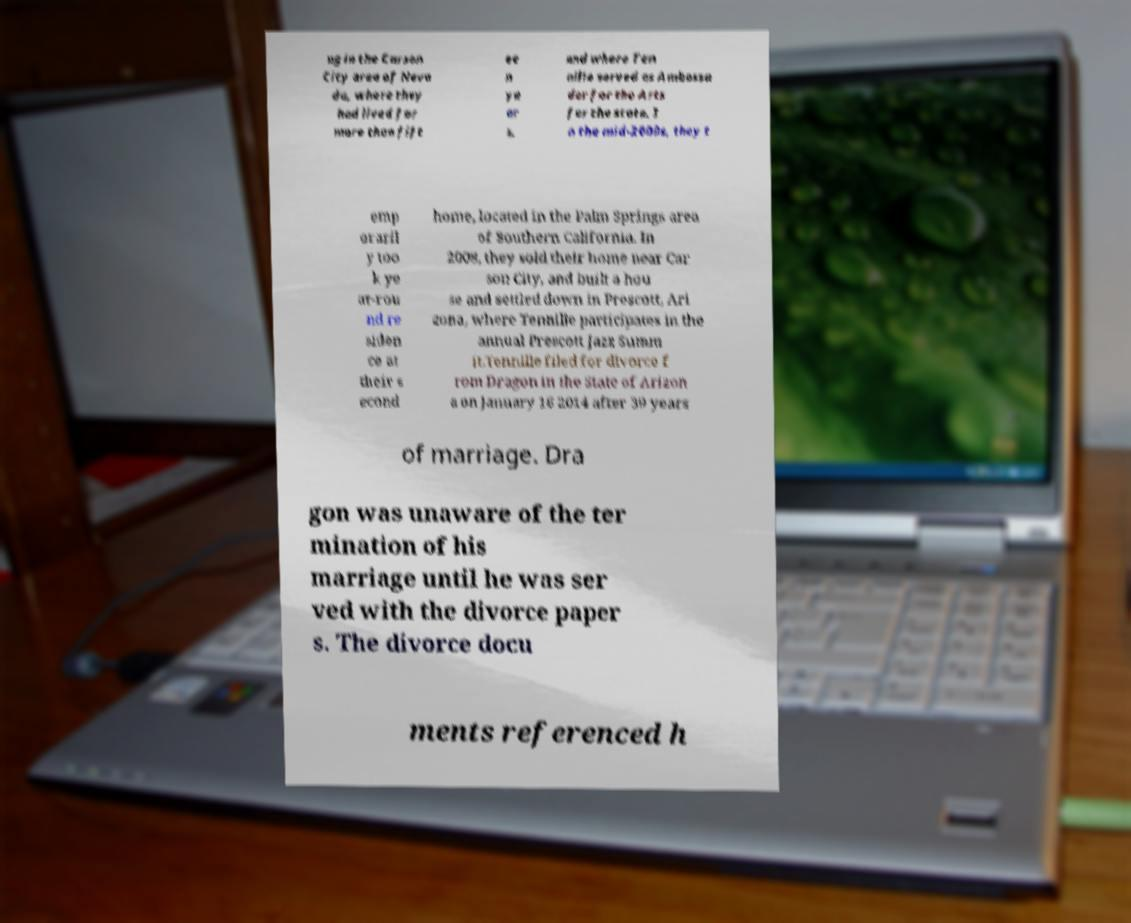There's text embedded in this image that I need extracted. Can you transcribe it verbatim? ng in the Carson City area of Neva da, where they had lived for more than fift ee n ye ar s, and where Ten nille served as Ambassa dor for the Arts for the state. I n the mid-2000s, they t emp oraril y too k ye ar-rou nd re siden ce at their s econd home, located in the Palm Springs area of Southern California. In 2008, they sold their home near Car son City, and built a hou se and settled down in Prescott, Ari zona, where Tennille participates in the annual Prescott Jazz Summ it.Tennille filed for divorce f rom Dragon in the State of Arizon a on January 16 2014 after 39 years of marriage. Dra gon was unaware of the ter mination of his marriage until he was ser ved with the divorce paper s. The divorce docu ments referenced h 